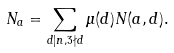Convert formula to latex. <formula><loc_0><loc_0><loc_500><loc_500>N _ { a } = \sum _ { d | n , 3 \nmid d } \mu ( d ) N ( a , d ) .</formula> 